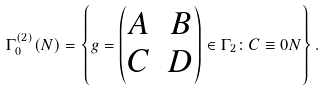<formula> <loc_0><loc_0><loc_500><loc_500>\Gamma _ { 0 } ^ { ( 2 ) } ( N ) = \left \{ g = \begin{pmatrix} A & B \\ C & D \end{pmatrix} \in \Gamma _ { 2 } \colon C \equiv 0 N \right \} .</formula> 